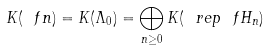Convert formula to latex. <formula><loc_0><loc_0><loc_500><loc_500>K ( \ f n ) = K ( \Lambda _ { 0 } ) = \bigoplus _ { n \geq 0 } K ( \ r e p \ f H _ { n } )</formula> 